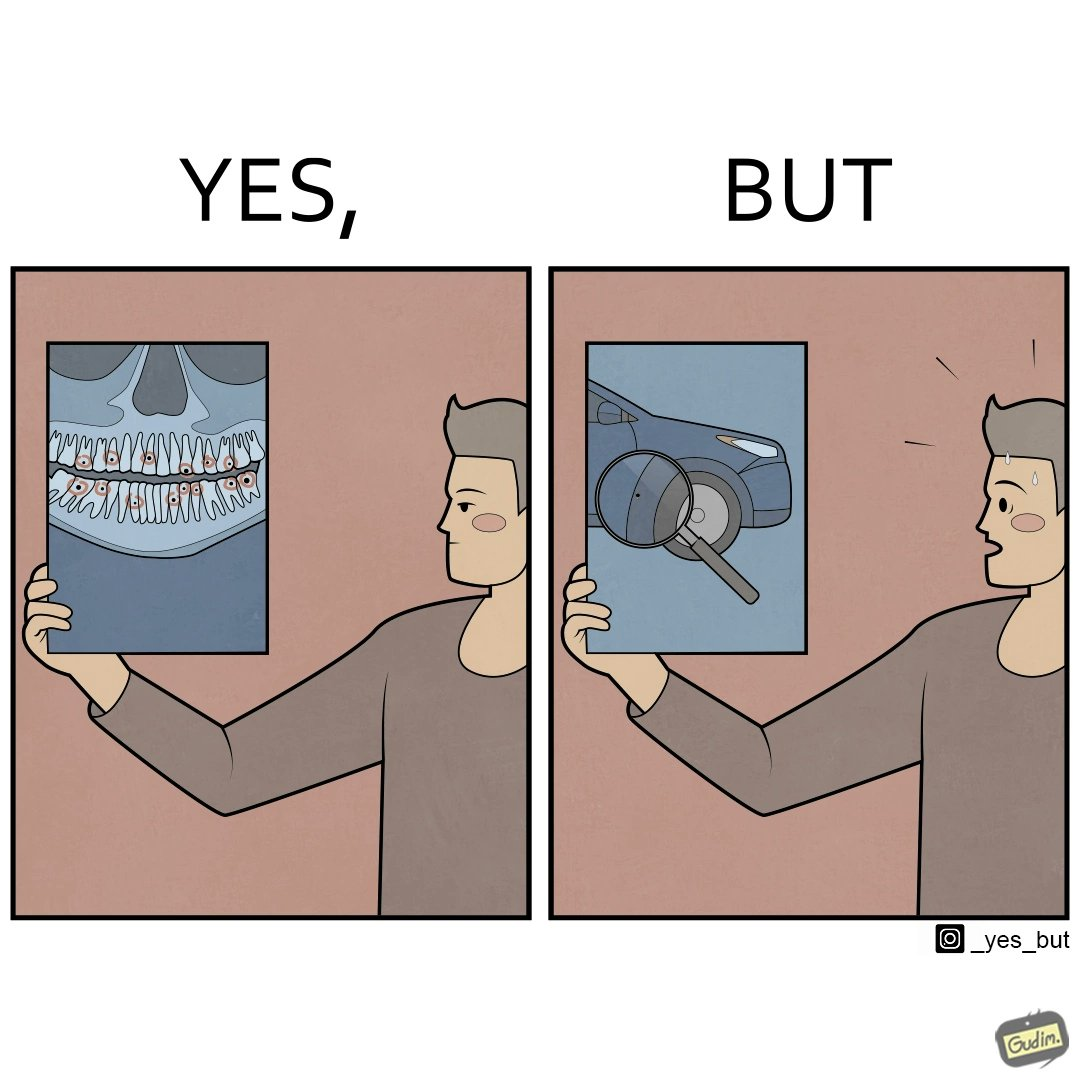What do you see in each half of this image? In the left part of the image: It is a man looking at an image of his cavity filled teeth In the right part of the image: It is a man looking worried after seeing a microscopic hole in his car 